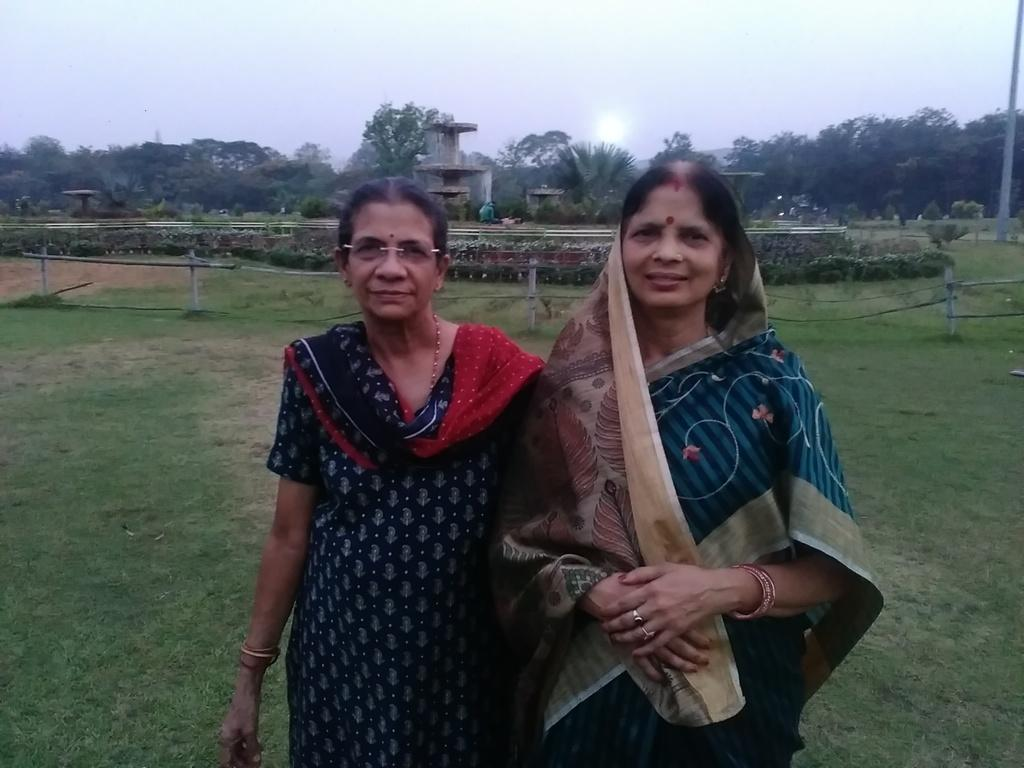How many women are in the image? There are two women standing in the image. What is the surface the women are standing on? The women are standing on the ground. What can be seen in the background of the image? There is a fence, plants, a fountain, trees, and the sky visible in the background of the image. What type of rock is being used as a serving dish for the eggnog in the image? There is no rock or eggnog present in the image. 